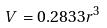Convert formula to latex. <formula><loc_0><loc_0><loc_500><loc_500>V = 0 . 2 8 3 3 r ^ { 3 }</formula> 